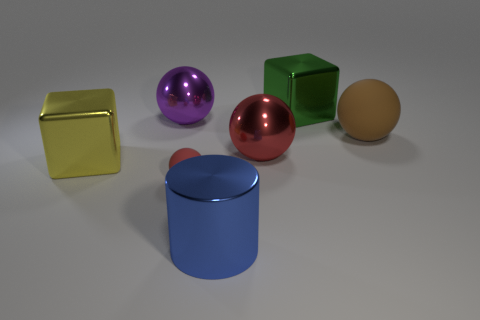Subtract all yellow balls. Subtract all purple blocks. How many balls are left? 4 Add 1 big matte objects. How many objects exist? 8 Subtract all blocks. How many objects are left? 5 Subtract all brown matte spheres. Subtract all big blue cylinders. How many objects are left? 5 Add 1 yellow blocks. How many yellow blocks are left? 2 Add 6 small gray objects. How many small gray objects exist? 6 Subtract 0 purple cubes. How many objects are left? 7 